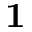<formula> <loc_0><loc_0><loc_500><loc_500>{ 1 }</formula> 